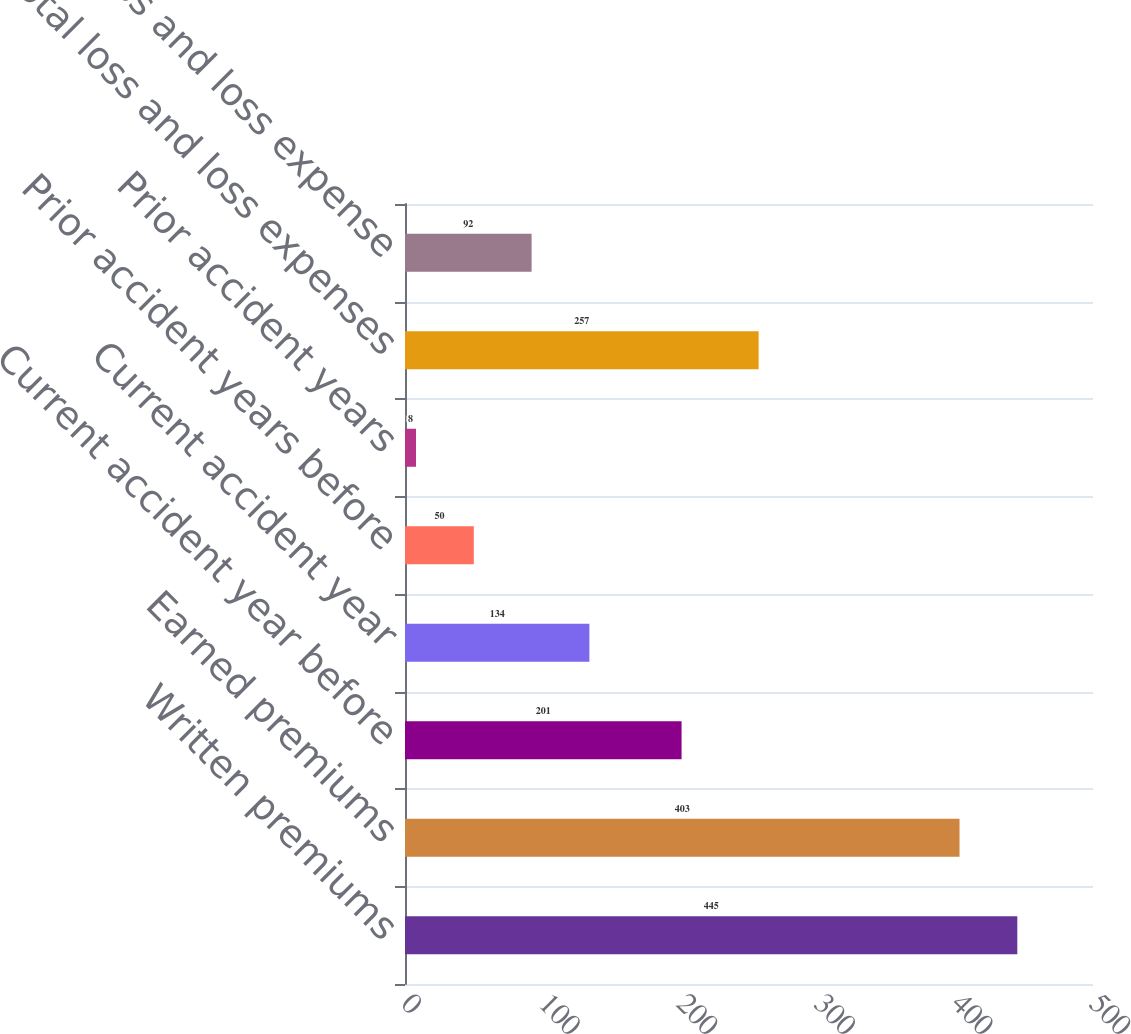<chart> <loc_0><loc_0><loc_500><loc_500><bar_chart><fcel>Written premiums<fcel>Earned premiums<fcel>Current accident year before<fcel>Current accident year<fcel>Prior accident years before<fcel>Prior accident years<fcel>Total loss and loss expenses<fcel>Total loss and loss expense<nl><fcel>445<fcel>403<fcel>201<fcel>134<fcel>50<fcel>8<fcel>257<fcel>92<nl></chart> 